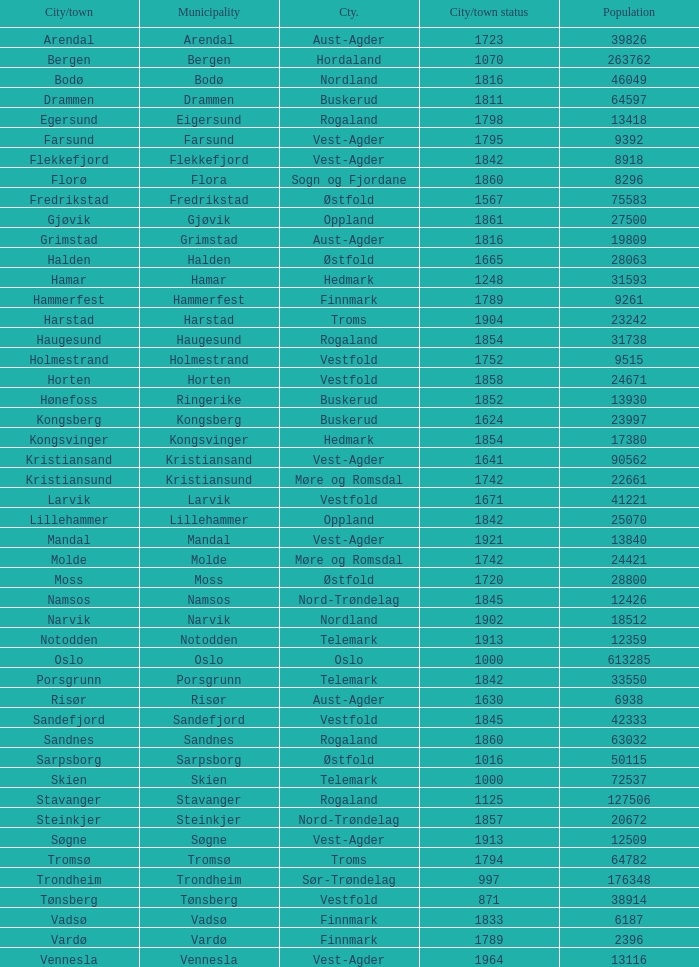Which municipalities located in the county of Finnmark have populations bigger than 6187.0? Hammerfest. 